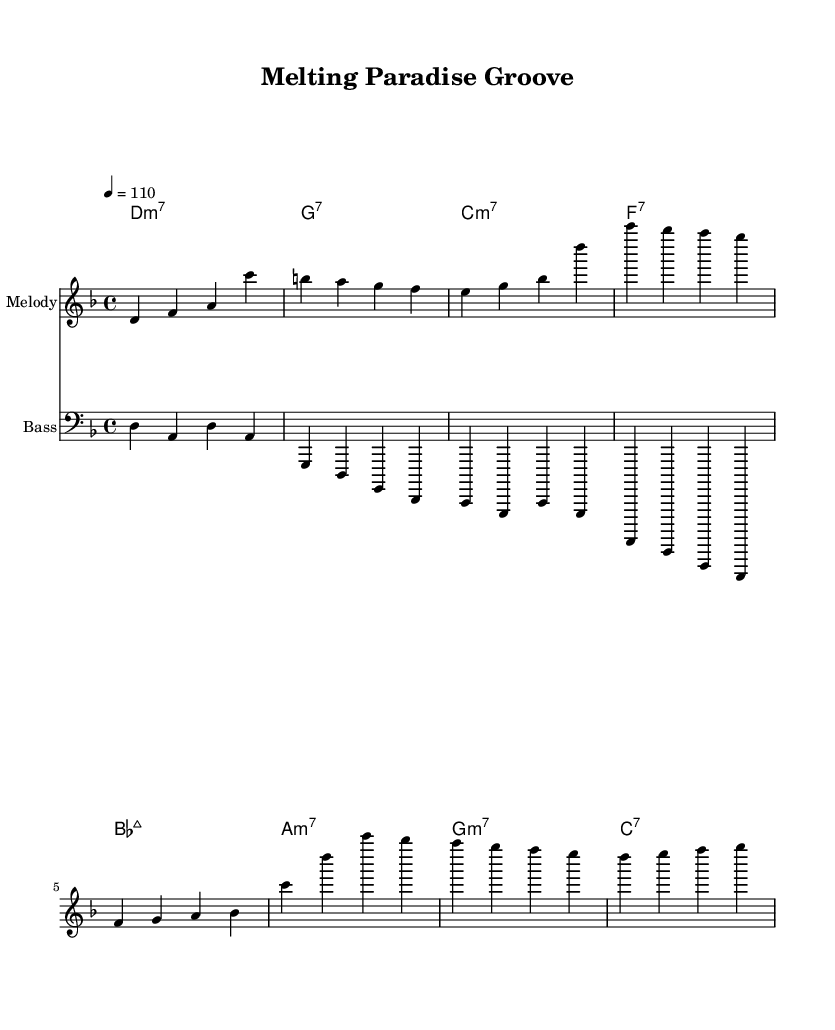What is the key signature of this music? The key signature is marked as D minor, which includes one flat (B flat) and is indicated in the global section of the code.
Answer: D minor What is the time signature of this piece? The time signature is indicated as 4/4 in the global section, which means there are four beats in each measure.
Answer: 4/4 What is the tempo indication of the music? The tempo is set at quarter note equals 110, which suggests a moderate pace for the piece. This is shown in the global section as '4 = 110'.
Answer: 110 How many measures are in the verse melody? The verse melody consists of 4 measures, as indicated by the grouping of notes and the structure defined within the melodyVerse variable.
Answer: 4 Which chord begins the chorus section? The first chord in the chorus section is B flat major 7, detailed in the chordNamesChorus variable highlighted within the score.
Answer: B flat major 7 What is the bass line's starting note? The bass line starts on the note D in the first measure, as shown in the bassLine variable, which is aligned with the melody and chord progression.
Answer: D How many unique chords are featured in the verse section? The verse section includes 4 unique chords: D minor 7, G7, C minor 7, and F7, as specified in the chordNamesVerse variable.
Answer: 4 